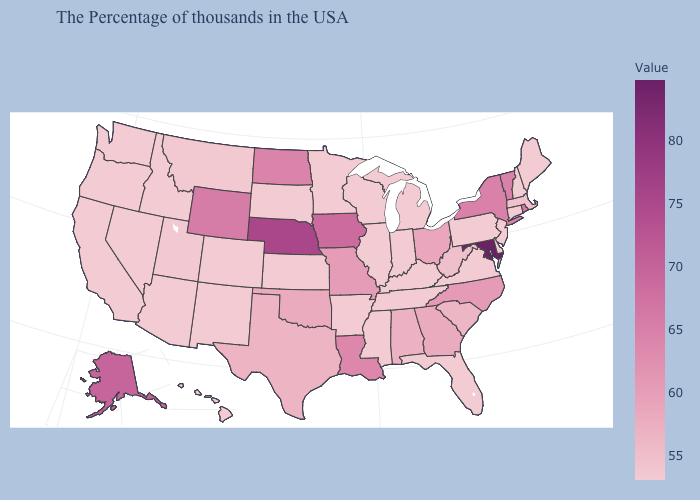Which states have the lowest value in the MidWest?
Write a very short answer. Michigan, Indiana, Wisconsin, Illinois, Minnesota, Kansas, South Dakota. Does Oklahoma have a higher value than Florida?
Concise answer only. Yes. Does Georgia have a lower value than Idaho?
Give a very brief answer. No. Among the states that border Pennsylvania , which have the highest value?
Answer briefly. Maryland. Does the map have missing data?
Concise answer only. No. Among the states that border Idaho , which have the highest value?
Write a very short answer. Wyoming. Does Wisconsin have the highest value in the USA?
Keep it brief. No. Among the states that border North Dakota , which have the lowest value?
Quick response, please. Minnesota, South Dakota. 